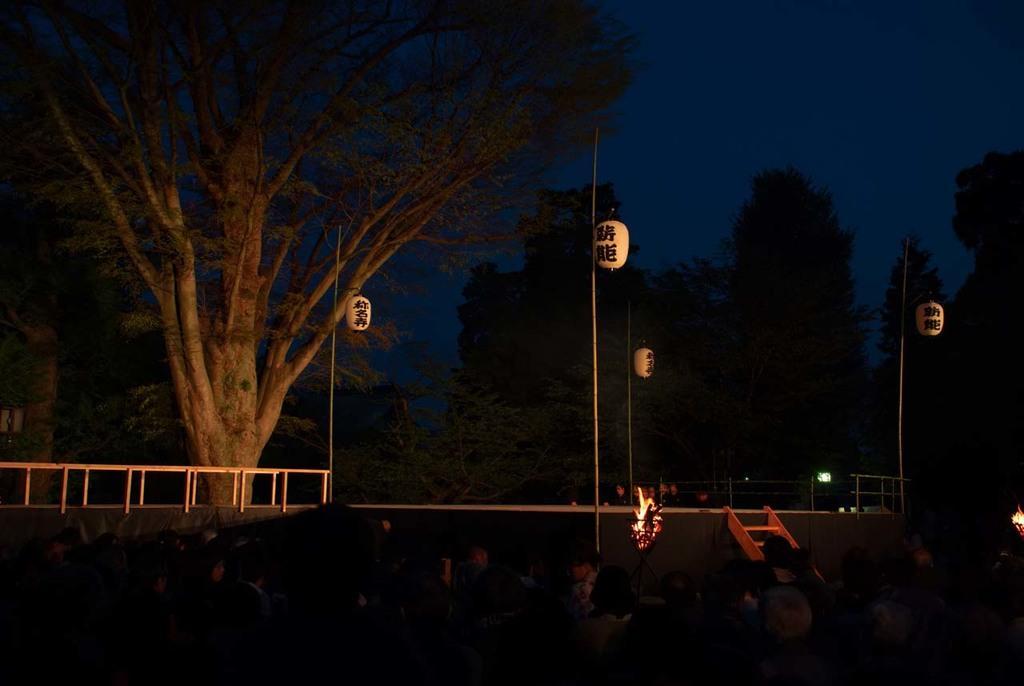In one or two sentences, can you explain what this image depicts? In this picture we can see a group of people and in the background we can see a ladder, trees, fire, sky and some objects. 